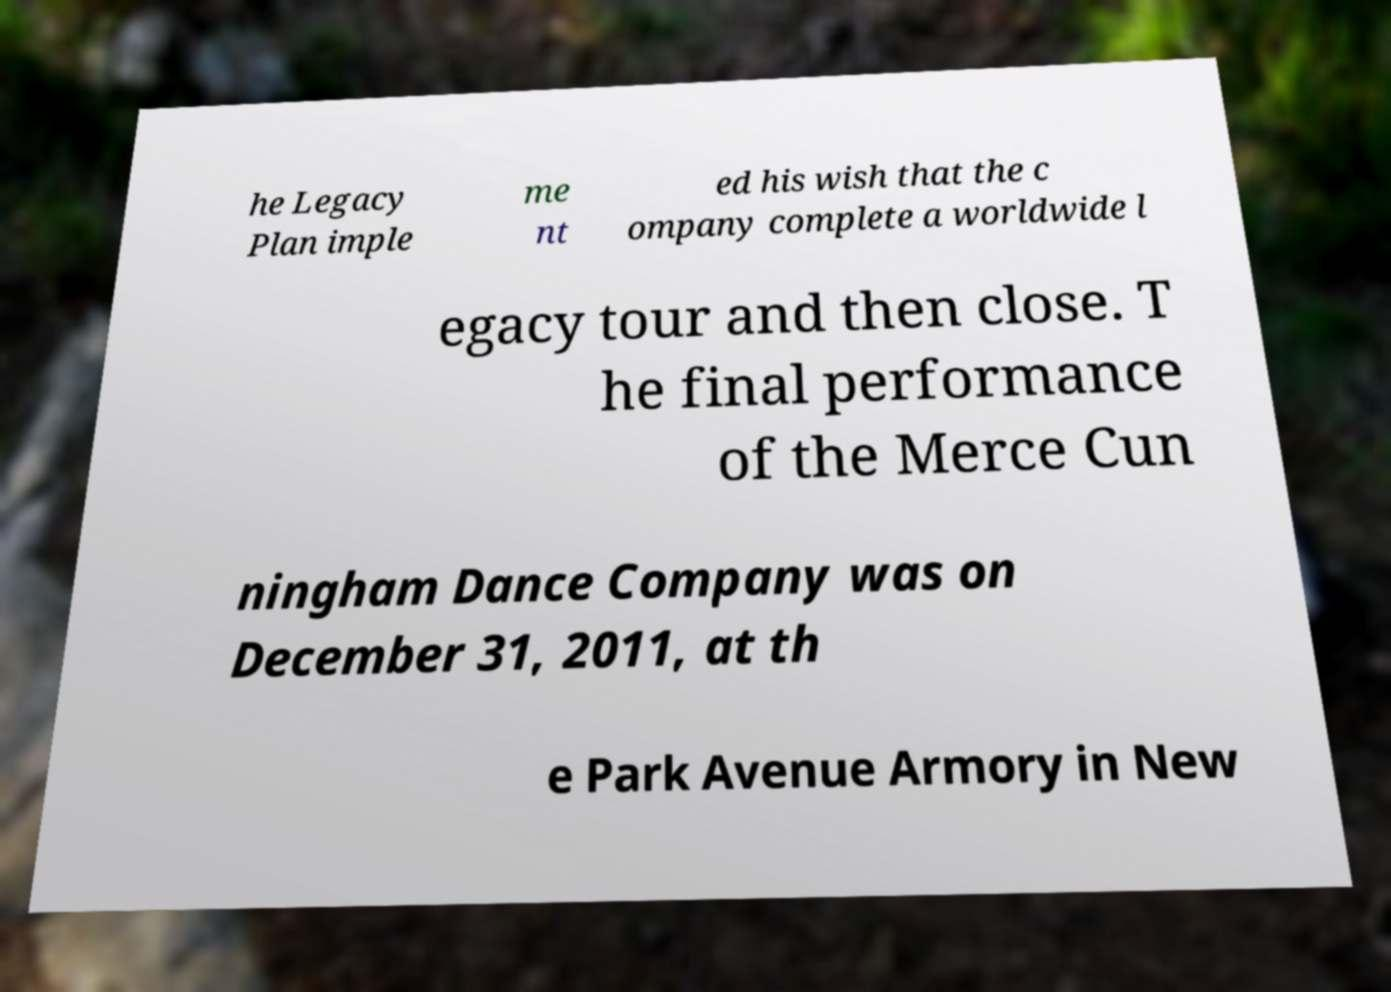For documentation purposes, I need the text within this image transcribed. Could you provide that? he Legacy Plan imple me nt ed his wish that the c ompany complete a worldwide l egacy tour and then close. T he final performance of the Merce Cun ningham Dance Company was on December 31, 2011, at th e Park Avenue Armory in New 